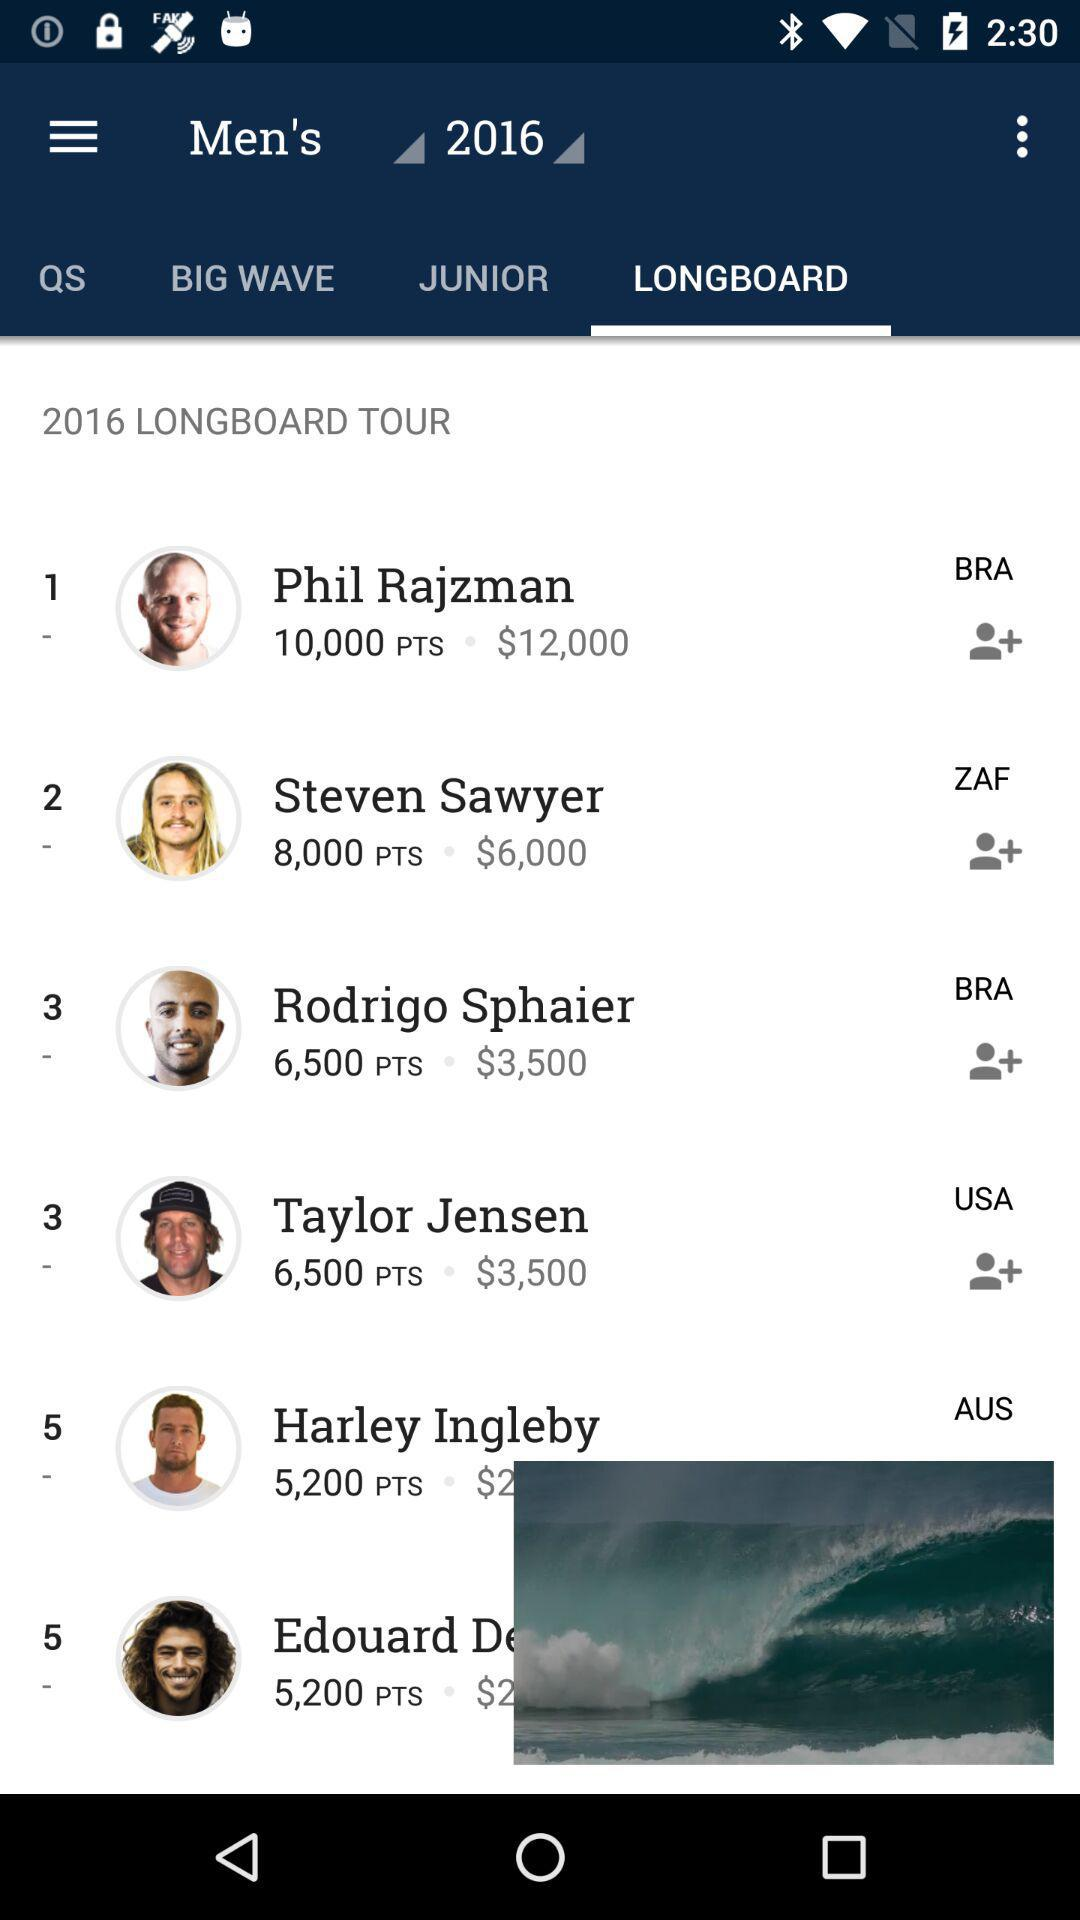What year is shown? The year is 2016. 